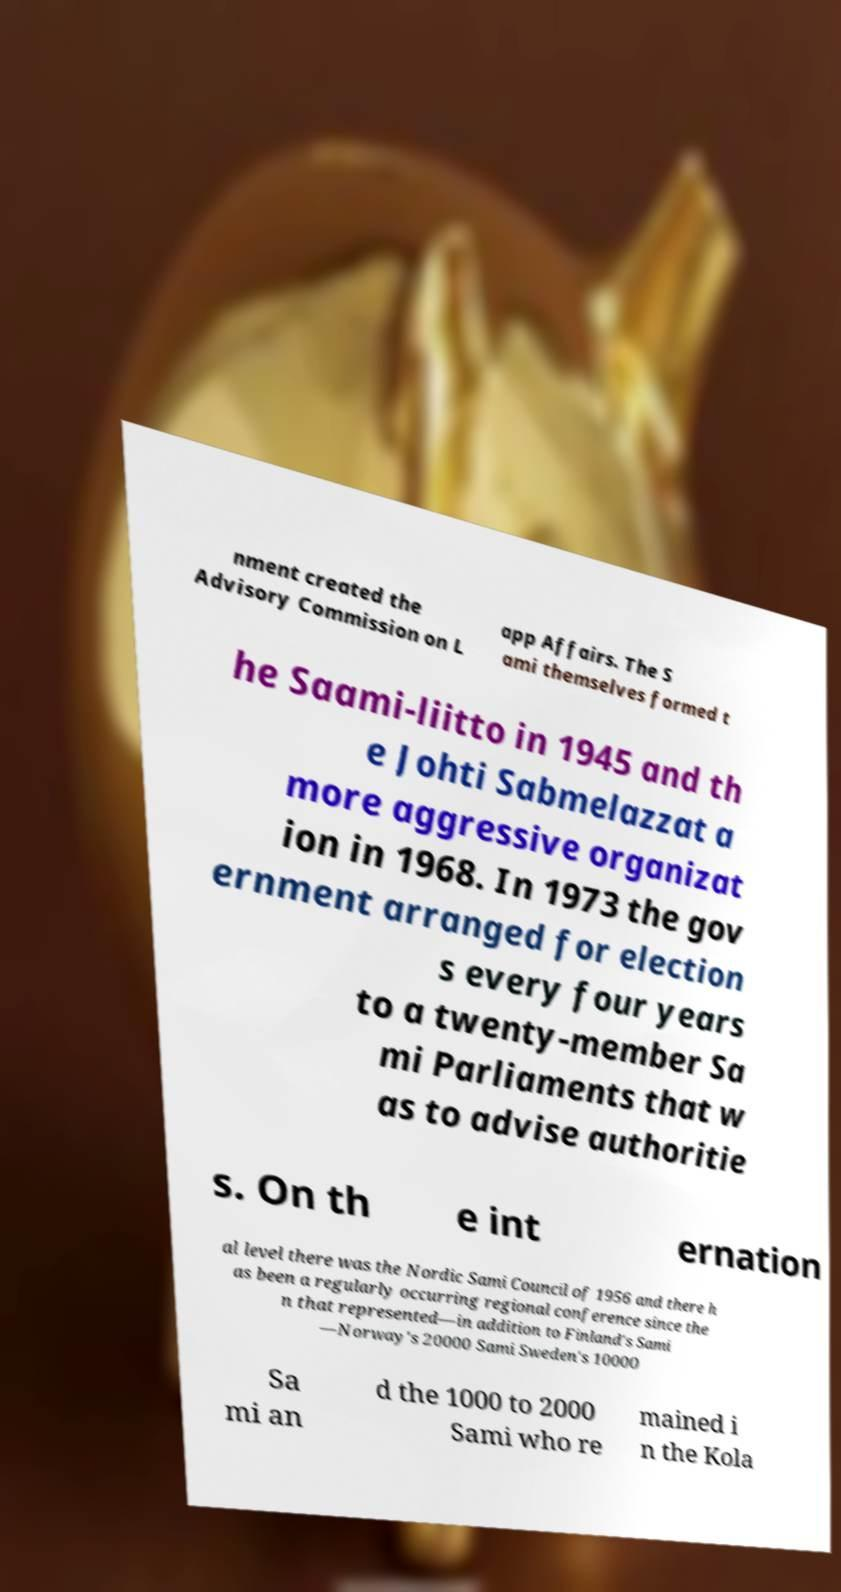Could you extract and type out the text from this image? nment created the Advisory Commission on L app Affairs. The S ami themselves formed t he Saami-liitto in 1945 and th e Johti Sabmelazzat a more aggressive organizat ion in 1968. In 1973 the gov ernment arranged for election s every four years to a twenty-member Sa mi Parliaments that w as to advise authoritie s. On th e int ernation al level there was the Nordic Sami Council of 1956 and there h as been a regularly occurring regional conference since the n that represented—in addition to Finland's Sami —Norway's 20000 Sami Sweden's 10000 Sa mi an d the 1000 to 2000 Sami who re mained i n the Kola 